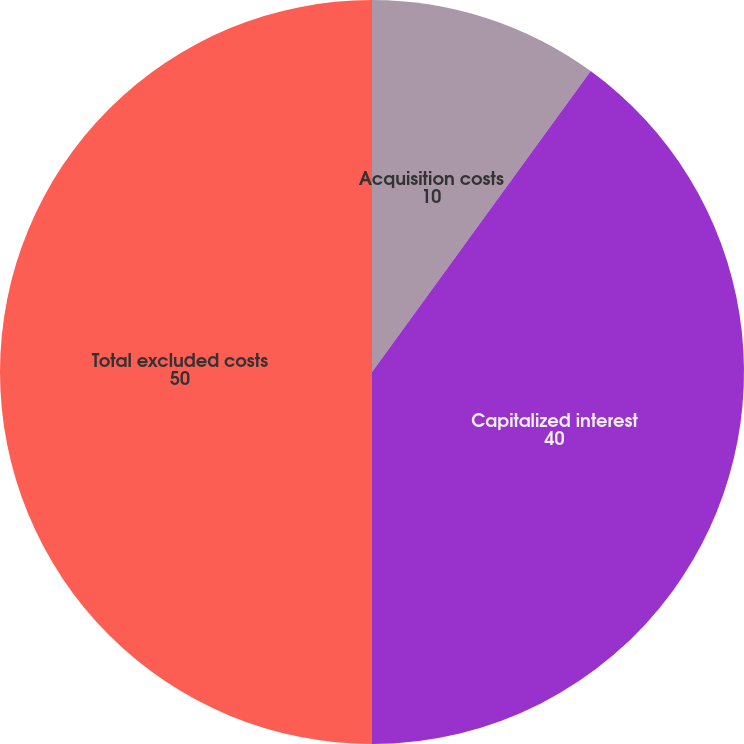Convert chart. <chart><loc_0><loc_0><loc_500><loc_500><pie_chart><fcel>Acquisition costs<fcel>Capitalized interest<fcel>Total excluded costs<nl><fcel>10.0%<fcel>40.0%<fcel>50.0%<nl></chart> 